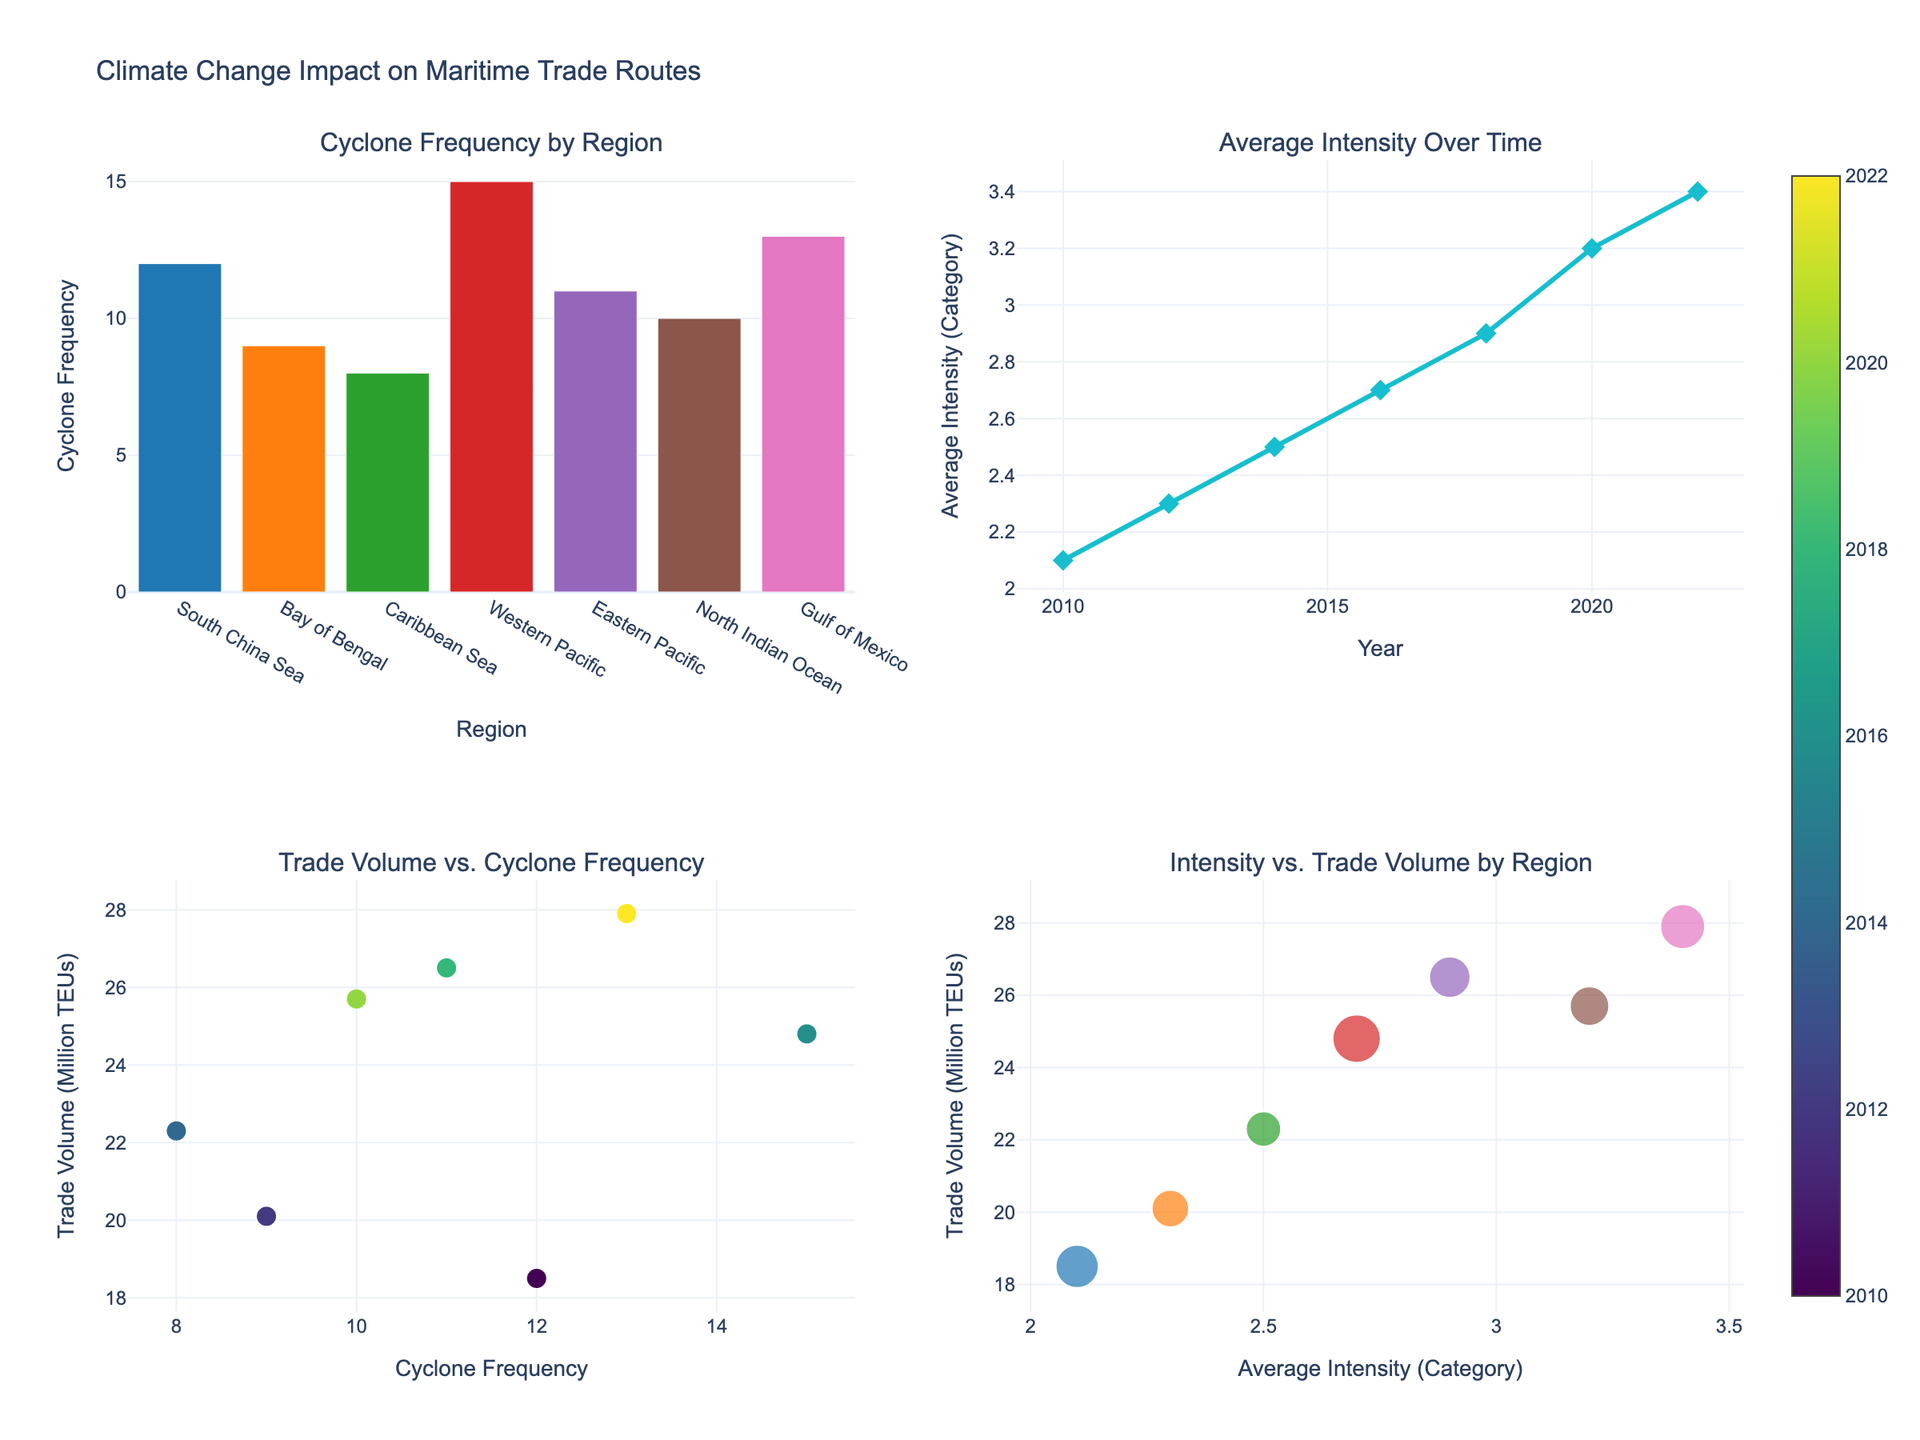What is the title of the figure? The title is usually located at the top of the figure and it provides a summary of what the figure represents. The title of this figure is "Climate Change Impact on Maritime Trade Routes".
Answer: Climate Change Impact on Maritime Trade Routes What is the average intensity of tropical cyclones in the year 2020? To find the average intensity in 2020, look at the "Average Intensity Over Time" subplot and locate the point where the x-axis indicates 2020. The corresponding y-value is the average intensity.
Answer: 3.2 Which region has the highest cyclone frequency? To determine the region with the highest cyclone frequency, refer to the "Cyclone Frequency by Region" bar chart. Find the tallest bar and check the x-axis label for the corresponding region.
Answer: Western Pacific In which year was the average cyclone intensity the highest? Look at the "Average Intensity Over Time" line chart and find the peak point on the y-axis. The x-axis value corresponding to this peak is the year with the highest average intensity.
Answer: 2022 How many regions experienced a cyclone frequency above 10? Refer to the "Cyclone Frequency by Region" bar chart and count the number of bars that extend beyond the y-axis value of 10.
Answer: 5 Is there a correlation between cyclone frequency and trade volume in the scatter plot? To determine correlation, examine the "Trade Volume vs. Cyclone Frequency" scatter plot. Look for a trend or pattern in the data points. If points trend upwards or downwards, there is a correlation. If there is no discernible pattern, correlation is weak or non-existent.
Answer: Weak positive correlation Which year shows a notable increase in average cyclone intensity compared to the previous year? Refer to the "Average Intensity Over Time" line chart. Look for years where there is a steep increase in the line connecting the points, indicating a noticeable rise in the average intensity.
Answer: 2018 Which region has the highest trade volume and what is its cyclone frequency? Check the "Intensity vs. Trade Volume by Region" bubble chart. Look for the largest bubble, which corresponds to the region with the highest trade volume. Then note its cyclone frequency by the size of the bubble or refer to the "Cyclone Frequency by Region" bar chart.
Answer: Gulf of Mexico, 13 How does the trade volume change as cyclone intensity increases in the scatter plot? On the "Intensity vs. Trade Volume by Region" bubble chart, observe the pattern of bubbles. Check if trade volume (y-axis) shows an increasing or decreasing trend as the average intensity (x-axis) changes.
Answer: Generally increases What is the region with the highest average intensity, and what is its correlation with trade volume? Use the "Cyclone Frequency by Region" and "Average Intensity Over Time" subplots to identify the region with the highest average intensity. Examine the "Intensity vs. Trade Volume by Region" bubble chart to check the trade volume correlation for that region. The highest average intensity is in the Gulf of Mexico.
Answer: Gulf of Mexico, positive correlation 